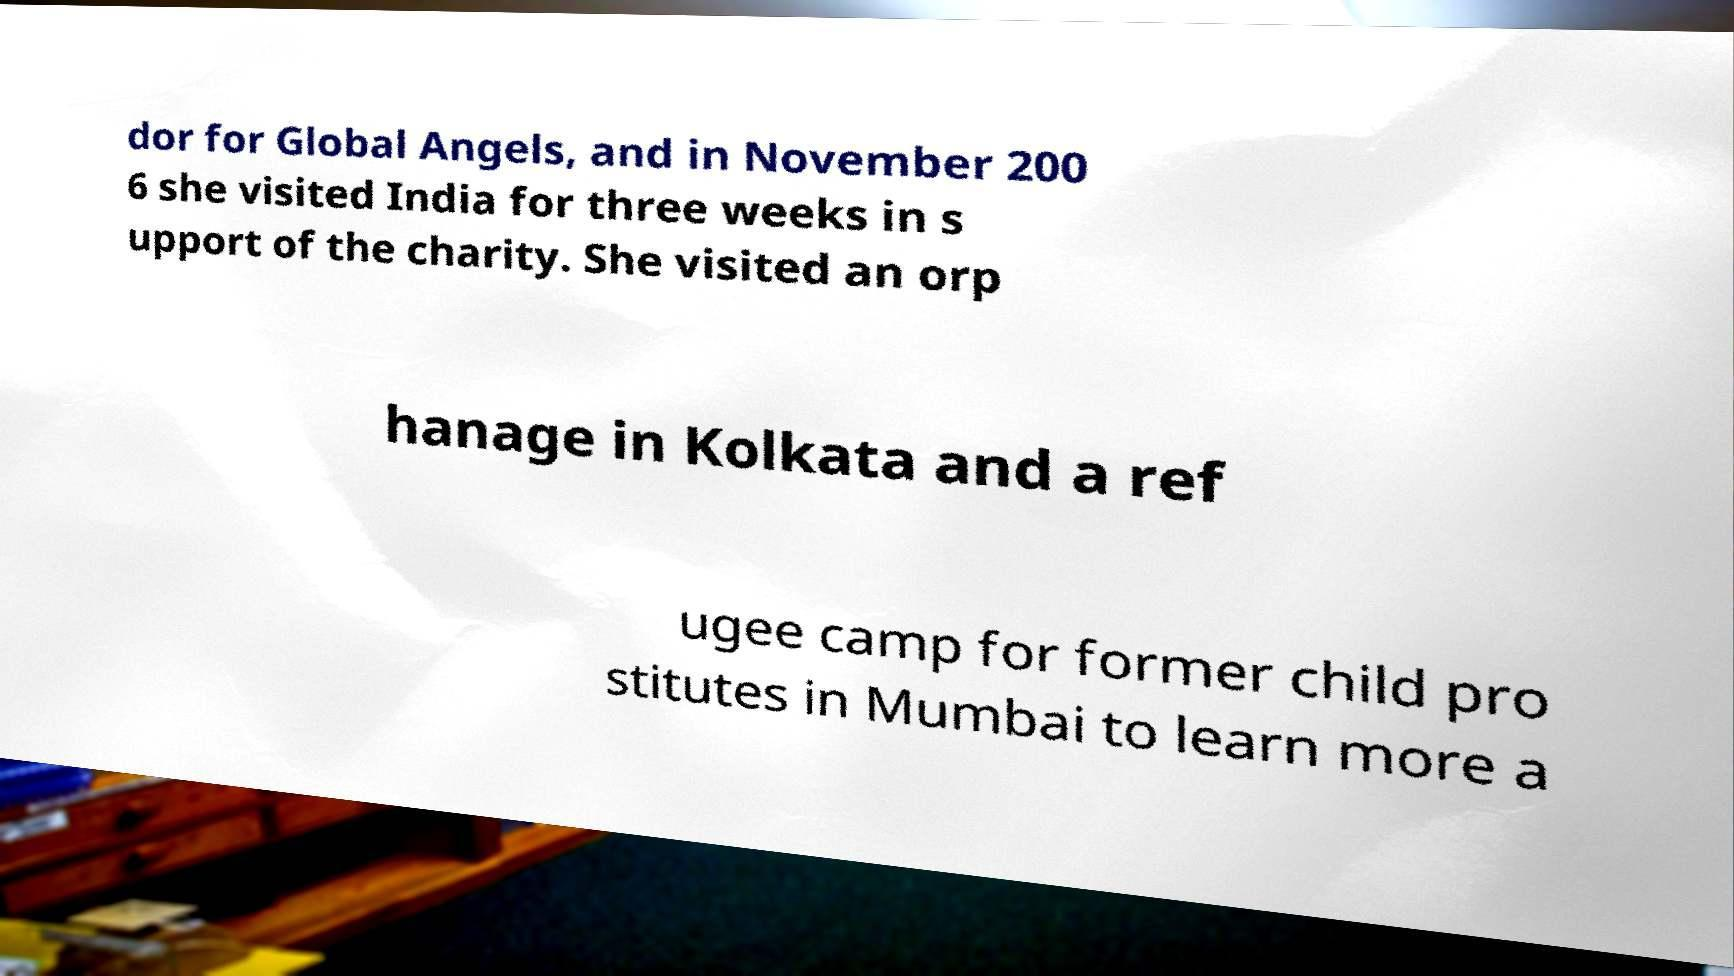I need the written content from this picture converted into text. Can you do that? dor for Global Angels, and in November 200 6 she visited India for three weeks in s upport of the charity. She visited an orp hanage in Kolkata and a ref ugee camp for former child pro stitutes in Mumbai to learn more a 